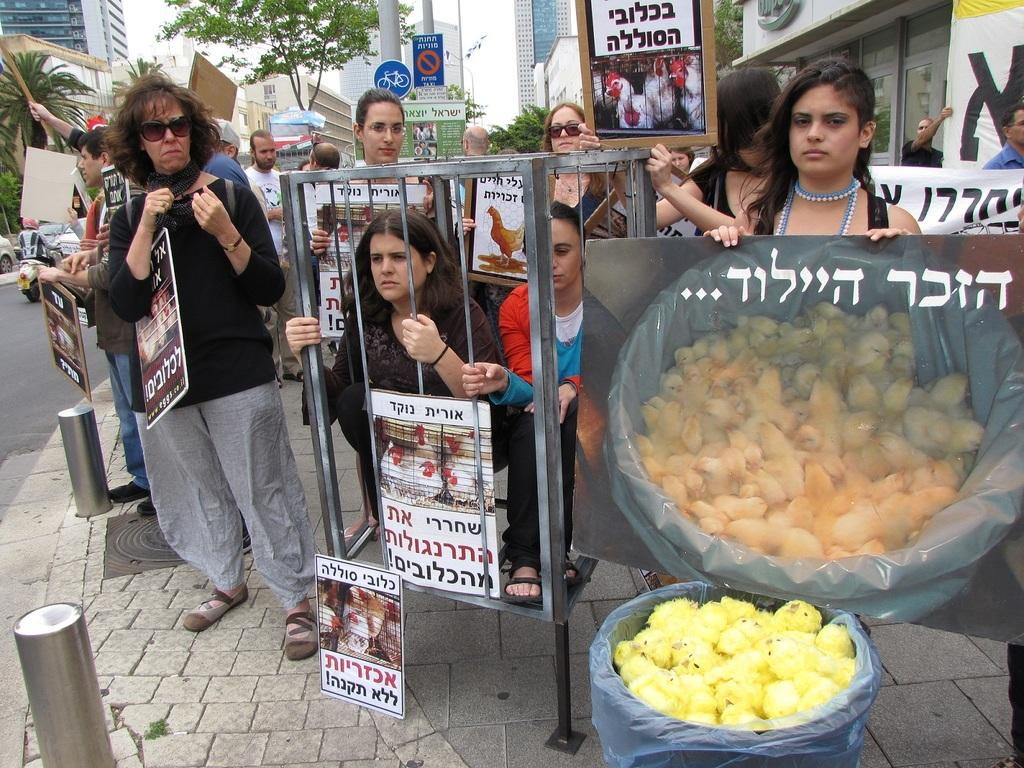What are the people in the image doing? The people in the image are standing and holding placards. What can be seen in the background of the image? There are trees, buildings, sign boards, and lamp posts visible in the background of the image. What type of wound can be seen on the person holding the placard in the image? There is no wound visible on any person in the image. How does the person holding the placard feel about the situation causing the shame in the image? The image does not convey any emotions or feelings of the people holding the placards, nor is there any indication of shame. 